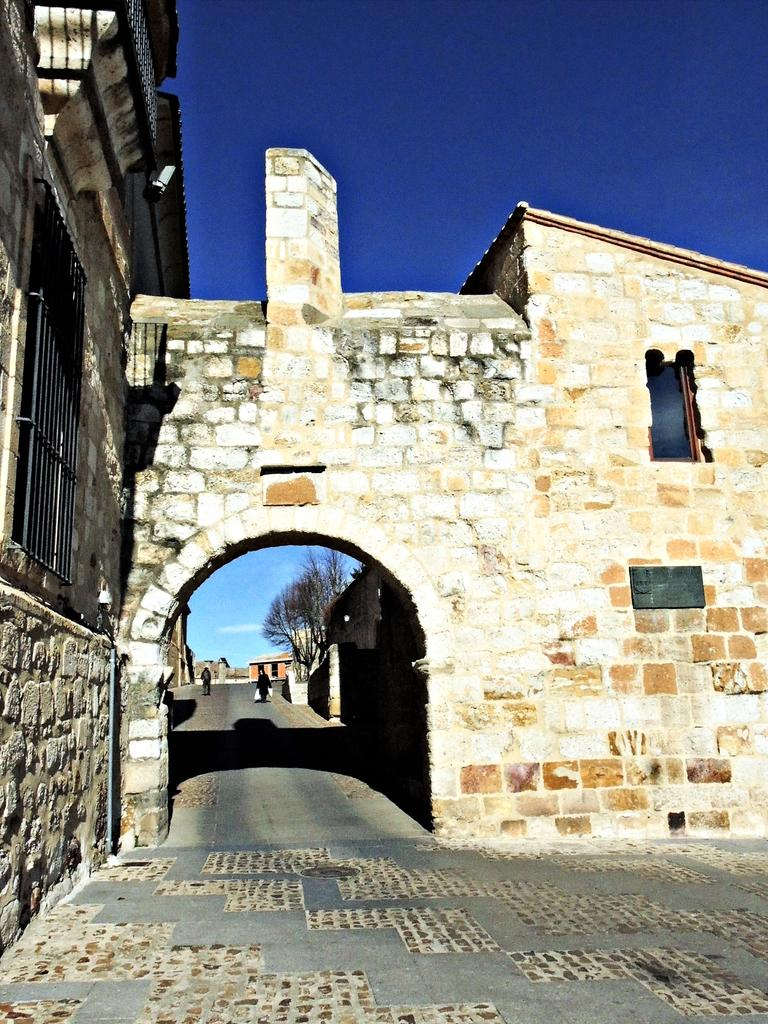What type of structure is present in the image? There is a building in the image. What else can be seen in the image besides the building? There is a pole, trees, sheds, and people on the road in the image. What is the condition of the sky in the image? The sky is visible at the top of the image. How many crows are sitting on the pole in the image? There are no crows present in the image. What question is being asked by the people on the road in the image? The image does not provide information about the questions being asked by the people on the road. 